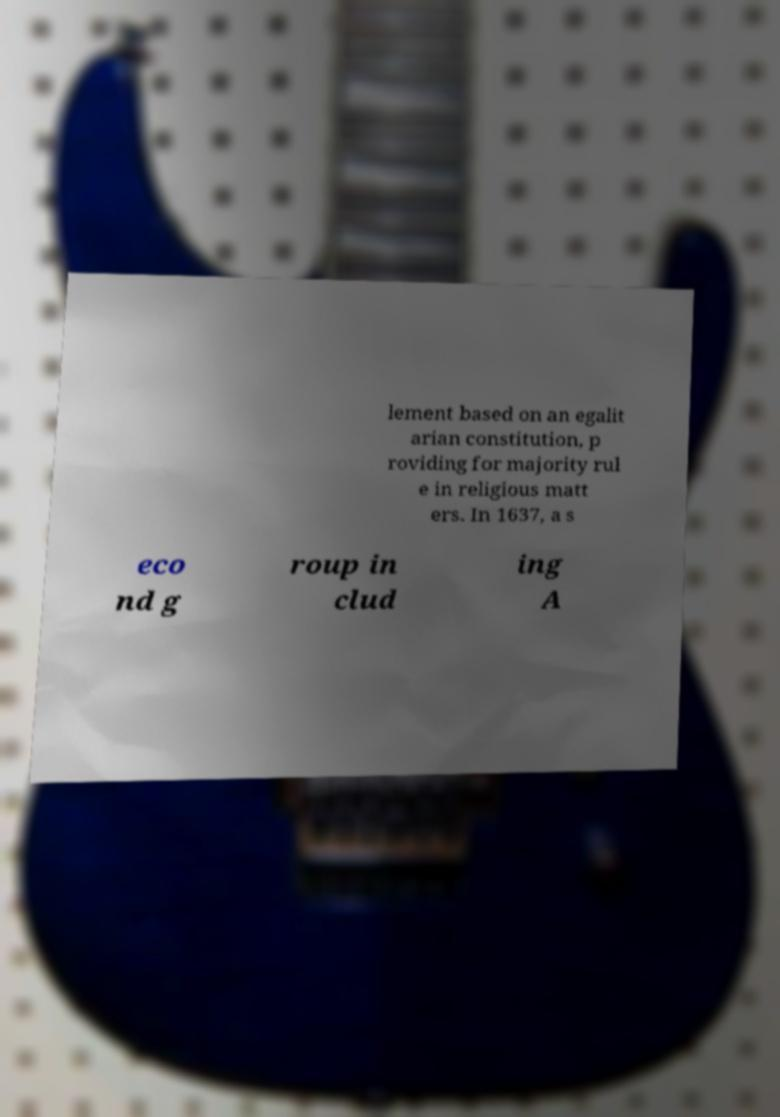Can you accurately transcribe the text from the provided image for me? lement based on an egalit arian constitution, p roviding for majority rul e in religious matt ers. In 1637, a s eco nd g roup in clud ing A 